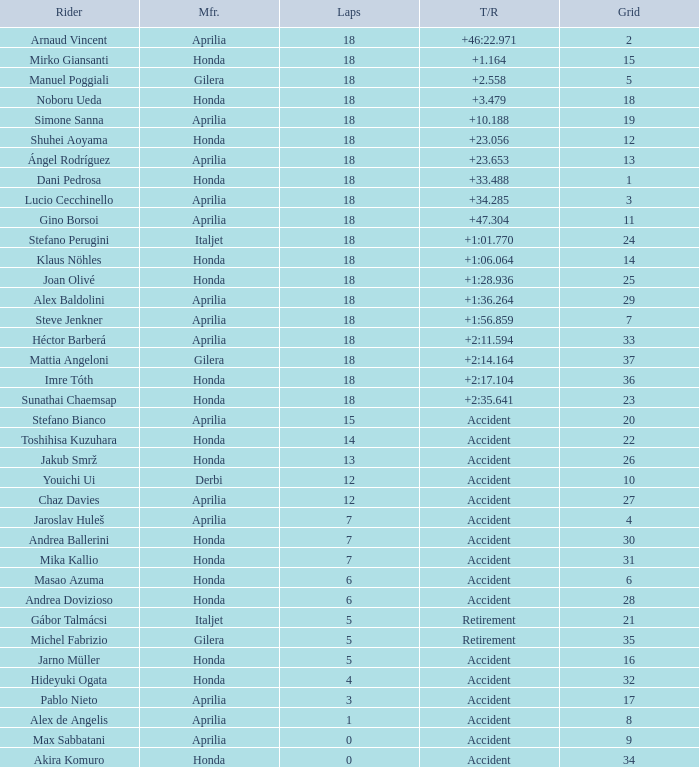Who is the rider with less than 15 laps, more than 32 grids, and an accident time/retired? Akira Komuro. 